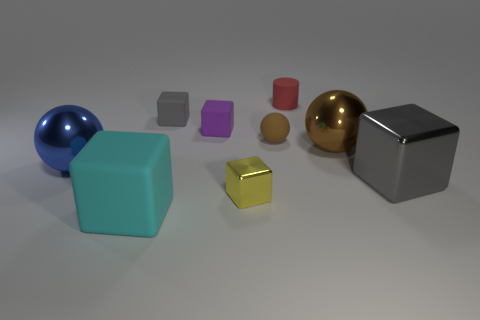Is there any other thing that is the same shape as the small red object?
Keep it short and to the point. No. What is the color of the metal thing in front of the big gray object?
Make the answer very short. Yellow. What material is the cube on the right side of the small red matte thing that is left of the brown object that is right of the red matte object?
Your answer should be very brief. Metal. What size is the cube right of the object that is behind the tiny gray rubber cube?
Give a very brief answer. Large. There is another big matte thing that is the same shape as the yellow thing; what is its color?
Offer a terse response. Cyan. How many other cubes have the same color as the big shiny block?
Your answer should be compact. 1. Is the blue sphere the same size as the cyan object?
Offer a very short reply. Yes. What is the material of the large gray thing?
Offer a very short reply. Metal. There is a tiny block that is made of the same material as the big brown object; what is its color?
Provide a succinct answer. Yellow. Does the cyan block have the same material as the tiny block in front of the tiny rubber sphere?
Offer a terse response. No. 